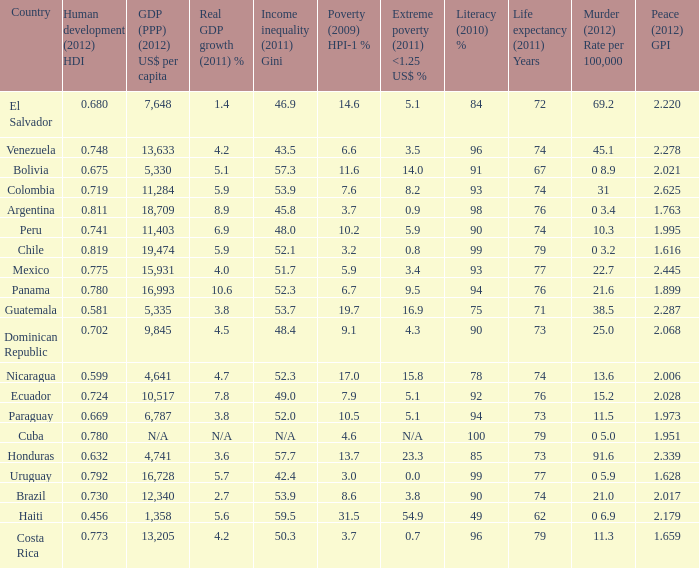What murder (2012) rate per 100,00 also has a 1.616 as the peace (2012) GPI? 0 3.2. Can you parse all the data within this table? {'header': ['Country', 'Human development (2012) HDI', 'GDP (PPP) (2012) US$ per capita', 'Real GDP growth (2011) %', 'Income inequality (2011) Gini', 'Poverty (2009) HPI-1 %', 'Extreme poverty (2011) <1.25 US$ %', 'Literacy (2010) %', 'Life expectancy (2011) Years', 'Murder (2012) Rate per 100,000', 'Peace (2012) GPI'], 'rows': [['El Salvador', '0.680', '7,648', '1.4', '46.9', '14.6', '5.1', '84', '72', '69.2', '2.220'], ['Venezuela', '0.748', '13,633', '4.2', '43.5', '6.6', '3.5', '96', '74', '45.1', '2.278'], ['Bolivia', '0.675', '5,330', '5.1', '57.3', '11.6', '14.0', '91', '67', '0 8.9', '2.021'], ['Colombia', '0.719', '11,284', '5.9', '53.9', '7.6', '8.2', '93', '74', '31', '2.625'], ['Argentina', '0.811', '18,709', '8.9', '45.8', '3.7', '0.9', '98', '76', '0 3.4', '1.763'], ['Peru', '0.741', '11,403', '6.9', '48.0', '10.2', '5.9', '90', '74', '10.3', '1.995'], ['Chile', '0.819', '19,474', '5.9', '52.1', '3.2', '0.8', '99', '79', '0 3.2', '1.616'], ['Mexico', '0.775', '15,931', '4.0', '51.7', '5.9', '3.4', '93', '77', '22.7', '2.445'], ['Panama', '0.780', '16,993', '10.6', '52.3', '6.7', '9.5', '94', '76', '21.6', '1.899'], ['Guatemala', '0.581', '5,335', '3.8', '53.7', '19.7', '16.9', '75', '71', '38.5', '2.287'], ['Dominican Republic', '0.702', '9,845', '4.5', '48.4', '9.1', '4.3', '90', '73', '25.0', '2.068'], ['Nicaragua', '0.599', '4,641', '4.7', '52.3', '17.0', '15.8', '78', '74', '13.6', '2.006'], ['Ecuador', '0.724', '10,517', '7.8', '49.0', '7.9', '5.1', '92', '76', '15.2', '2.028'], ['Paraguay', '0.669', '6,787', '3.8', '52.0', '10.5', '5.1', '94', '73', '11.5', '1.973'], ['Cuba', '0.780', 'N/A', 'N/A', 'N/A', '4.6', 'N/A', '100', '79', '0 5.0', '1.951'], ['Honduras', '0.632', '4,741', '3.6', '57.7', '13.7', '23.3', '85', '73', '91.6', '2.339'], ['Uruguay', '0.792', '16,728', '5.7', '42.4', '3.0', '0.0', '99', '77', '0 5.9', '1.628'], ['Brazil', '0.730', '12,340', '2.7', '53.9', '8.6', '3.8', '90', '74', '21.0', '2.017'], ['Haiti', '0.456', '1,358', '5.6', '59.5', '31.5', '54.9', '49', '62', '0 6.9', '2.179'], ['Costa Rica', '0.773', '13,205', '4.2', '50.3', '3.7', '0.7', '96', '79', '11.3', '1.659']]} 